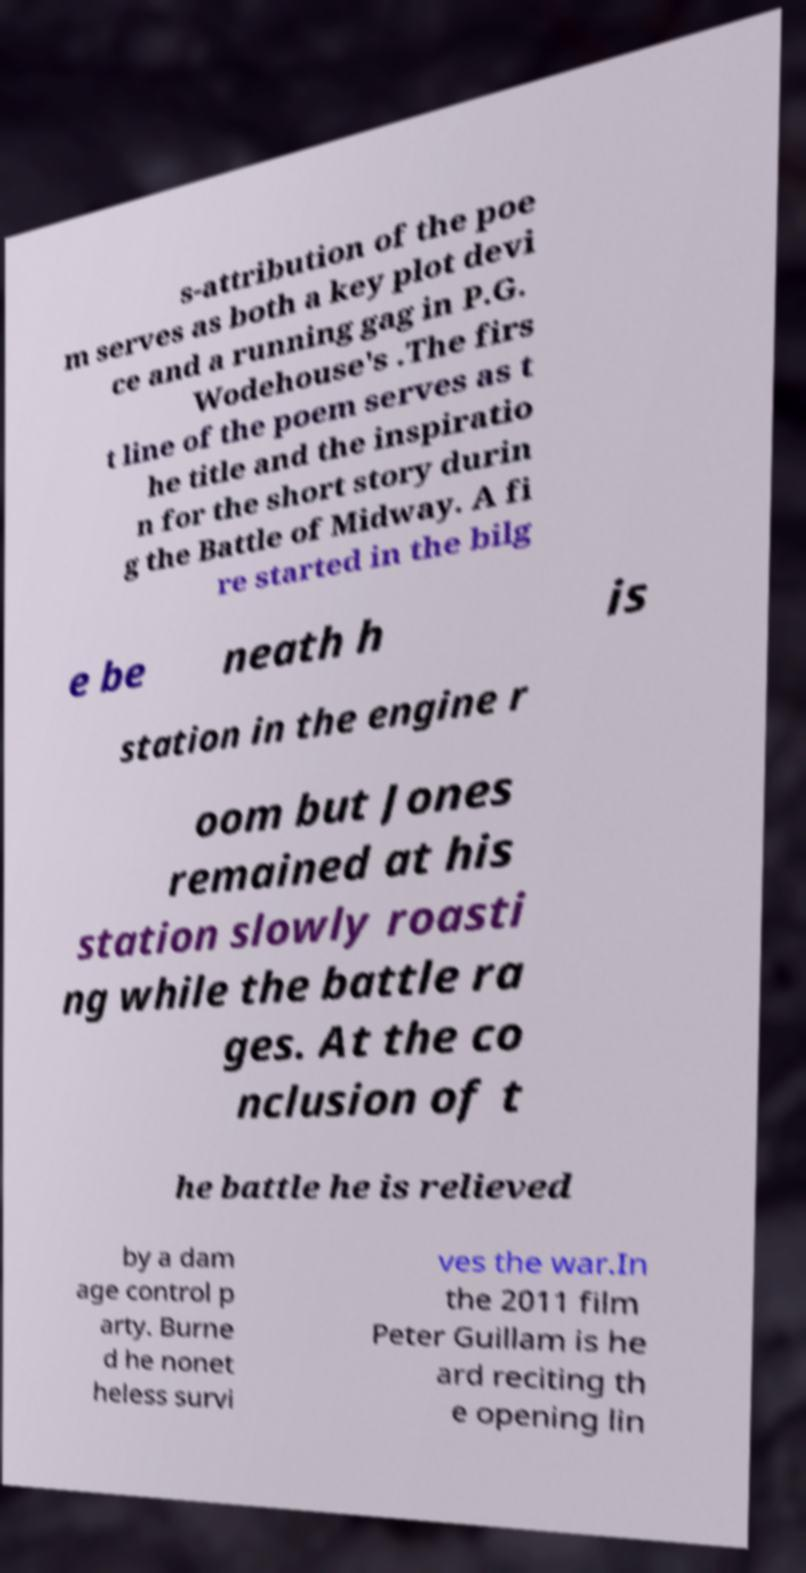For documentation purposes, I need the text within this image transcribed. Could you provide that? s-attribution of the poe m serves as both a key plot devi ce and a running gag in P.G. Wodehouse's .The firs t line of the poem serves as t he title and the inspiratio n for the short story durin g the Battle of Midway. A fi re started in the bilg e be neath h is station in the engine r oom but Jones remained at his station slowly roasti ng while the battle ra ges. At the co nclusion of t he battle he is relieved by a dam age control p arty. Burne d he nonet heless survi ves the war.In the 2011 film Peter Guillam is he ard reciting th e opening lin 